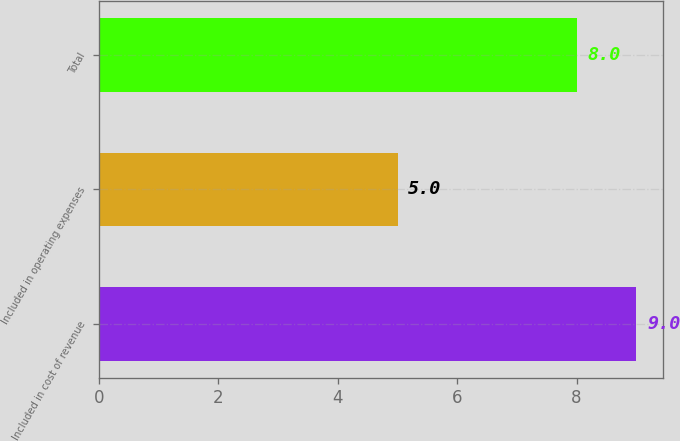<chart> <loc_0><loc_0><loc_500><loc_500><bar_chart><fcel>Included in cost of revenue<fcel>Included in operating expenses<fcel>Total<nl><fcel>9<fcel>5<fcel>8<nl></chart> 